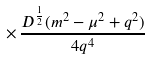<formula> <loc_0><loc_0><loc_500><loc_500>\times \, \frac { D ^ { \frac { 1 } { 2 } } ( m ^ { 2 } - \mu ^ { 2 } + q ^ { 2 } ) } { 4 q ^ { 4 } }</formula> 